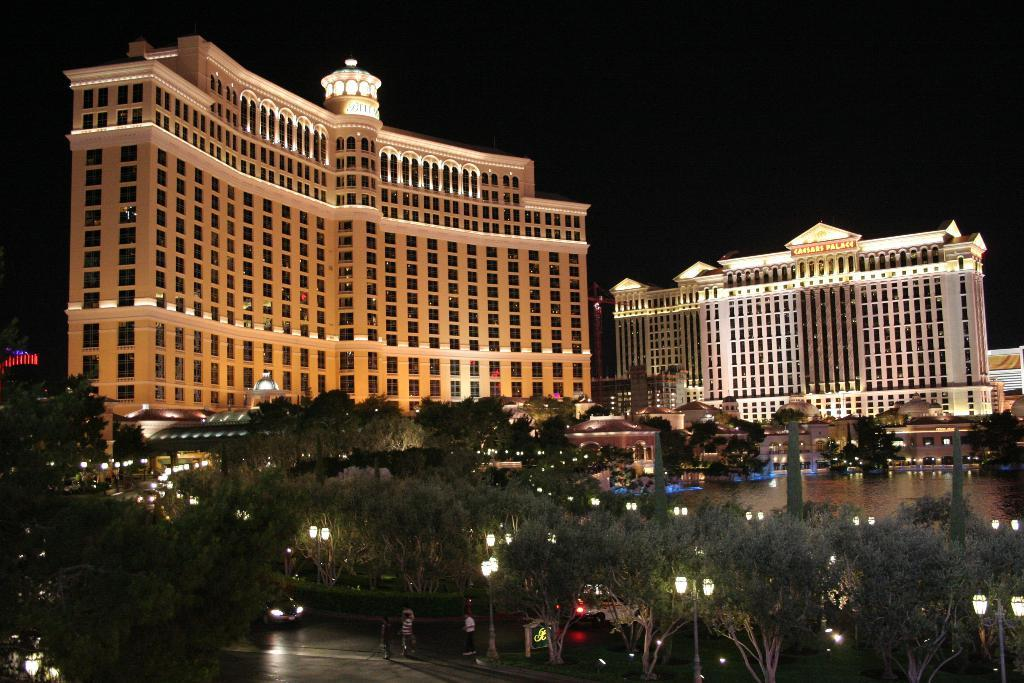What can be seen in the image? There are people, trees, poles, lights, vehicles on the road, water, and buildings in the image. Can you describe the environment in the image? The environment in the image includes trees, water, and buildings, suggesting it might be an outdoor or urban setting. What type of structures are visible in the image? There are poles and buildings visible in the image. What is the condition of the sky in the image? The background of the image is dark, which might suggest it is nighttime or the sky is overcast. What type of flower can be smelled in the image? There is no flower present in the image, and therefore no smell can be associated with it. How many teeth can be seen in the image? There are no teeth visible in the image. 